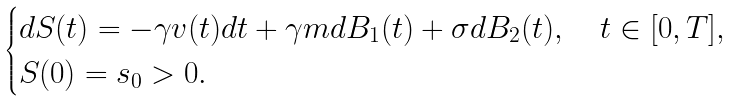<formula> <loc_0><loc_0><loc_500><loc_500>\begin{cases} d S ( t ) = - \gamma v ( t ) d t + \gamma m d B _ { 1 } ( t ) + \sigma d B _ { 2 } ( t ) , \quad t \in [ 0 , T ] , \\ S ( 0 ) = s _ { 0 } > 0 . \end{cases}</formula> 